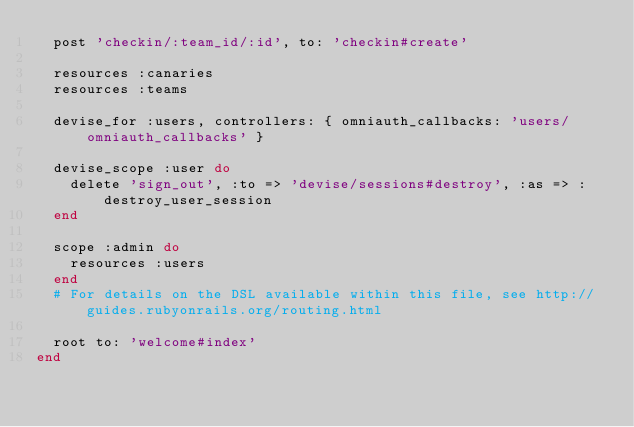Convert code to text. <code><loc_0><loc_0><loc_500><loc_500><_Ruby_>  post 'checkin/:team_id/:id', to: 'checkin#create'

  resources :canaries
  resources :teams

  devise_for :users, controllers: { omniauth_callbacks: 'users/omniauth_callbacks' }

  devise_scope :user do
    delete 'sign_out', :to => 'devise/sessions#destroy', :as => :destroy_user_session
  end

  scope :admin do
    resources :users
  end
  # For details on the DSL available within this file, see http://guides.rubyonrails.org/routing.html

  root to: 'welcome#index'
end
</code> 